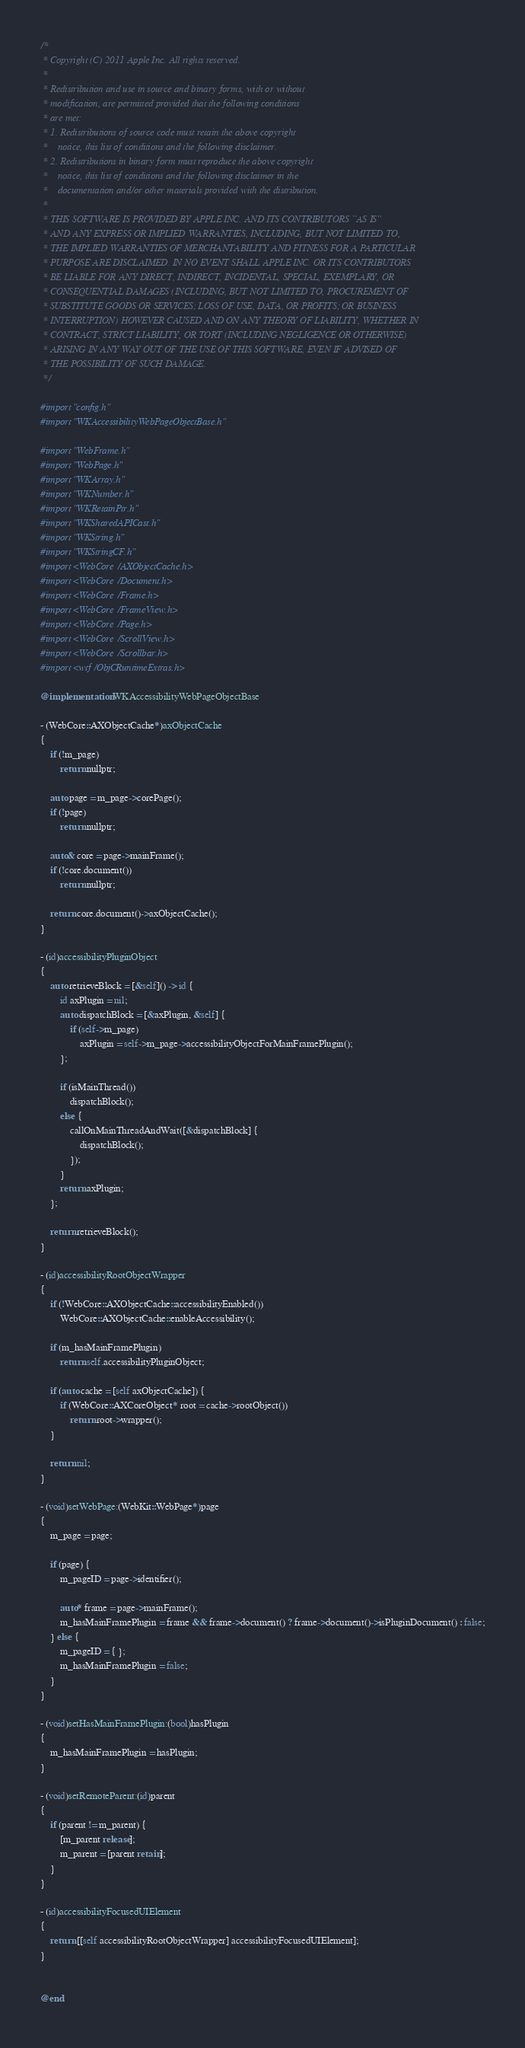Convert code to text. <code><loc_0><loc_0><loc_500><loc_500><_ObjectiveC_>/*
 * Copyright (C) 2011 Apple Inc. All rights reserved.
 *
 * Redistribution and use in source and binary forms, with or without
 * modification, are permitted provided that the following conditions
 * are met:
 * 1. Redistributions of source code must retain the above copyright
 *    notice, this list of conditions and the following disclaimer.
 * 2. Redistributions in binary form must reproduce the above copyright
 *    notice, this list of conditions and the following disclaimer in the
 *    documentation and/or other materials provided with the distribution.
 *
 * THIS SOFTWARE IS PROVIDED BY APPLE INC. AND ITS CONTRIBUTORS ``AS IS''
 * AND ANY EXPRESS OR IMPLIED WARRANTIES, INCLUDING, BUT NOT LIMITED TO,
 * THE IMPLIED WARRANTIES OF MERCHANTABILITY AND FITNESS FOR A PARTICULAR
 * PURPOSE ARE DISCLAIMED. IN NO EVENT SHALL APPLE INC. OR ITS CONTRIBUTORS
 * BE LIABLE FOR ANY DIRECT, INDIRECT, INCIDENTAL, SPECIAL, EXEMPLARY, OR
 * CONSEQUENTIAL DAMAGES (INCLUDING, BUT NOT LIMITED TO, PROCUREMENT OF
 * SUBSTITUTE GOODS OR SERVICES; LOSS OF USE, DATA, OR PROFITS; OR BUSINESS
 * INTERRUPTION) HOWEVER CAUSED AND ON ANY THEORY OF LIABILITY, WHETHER IN
 * CONTRACT, STRICT LIABILITY, OR TORT (INCLUDING NEGLIGENCE OR OTHERWISE)
 * ARISING IN ANY WAY OUT OF THE USE OF THIS SOFTWARE, EVEN IF ADVISED OF
 * THE POSSIBILITY OF SUCH DAMAGE.
 */

#import "config.h"
#import "WKAccessibilityWebPageObjectBase.h"

#import "WebFrame.h"
#import "WebPage.h"
#import "WKArray.h"
#import "WKNumber.h"
#import "WKRetainPtr.h"
#import "WKSharedAPICast.h"
#import "WKString.h"
#import "WKStringCF.h"
#import <WebCore/AXObjectCache.h>
#import <WebCore/Document.h>
#import <WebCore/Frame.h>
#import <WebCore/FrameView.h>
#import <WebCore/Page.h>
#import <WebCore/ScrollView.h>
#import <WebCore/Scrollbar.h>
#import <wtf/ObjCRuntimeExtras.h>

@implementation WKAccessibilityWebPageObjectBase

- (WebCore::AXObjectCache*)axObjectCache
{
    if (!m_page)
        return nullptr;

    auto page = m_page->corePage();
    if (!page)
        return nullptr;

    auto& core = page->mainFrame();
    if (!core.document())
        return nullptr;

    return core.document()->axObjectCache();
}

- (id)accessibilityPluginObject
{
    auto retrieveBlock = [&self]() -> id {
        id axPlugin = nil;
        auto dispatchBlock = [&axPlugin, &self] {
            if (self->m_page)
                axPlugin = self->m_page->accessibilityObjectForMainFramePlugin();
        };

        if (isMainThread())
            dispatchBlock();
        else {
            callOnMainThreadAndWait([&dispatchBlock] {
                dispatchBlock();
            });
        }
        return axPlugin;
    };
    
    return retrieveBlock();
}

- (id)accessibilityRootObjectWrapper
{
    if (!WebCore::AXObjectCache::accessibilityEnabled())
        WebCore::AXObjectCache::enableAccessibility();

    if (m_hasMainFramePlugin)
        return self.accessibilityPluginObject;

    if (auto cache = [self axObjectCache]) {
        if (WebCore::AXCoreObject* root = cache->rootObject())
            return root->wrapper();
    }

    return nil;
}

- (void)setWebPage:(WebKit::WebPage*)page
{
    m_page = page;

    if (page) {
        m_pageID = page->identifier();

        auto* frame = page->mainFrame();
        m_hasMainFramePlugin = frame && frame->document() ? frame->document()->isPluginDocument() : false;
    } else {
        m_pageID = { };
        m_hasMainFramePlugin = false;
    }
}

- (void)setHasMainFramePlugin:(bool)hasPlugin
{
    m_hasMainFramePlugin = hasPlugin;
}

- (void)setRemoteParent:(id)parent
{
    if (parent != m_parent) {
        [m_parent release];
        m_parent = [parent retain];
    }
}

- (id)accessibilityFocusedUIElement
{
    return [[self accessibilityRootObjectWrapper] accessibilityFocusedUIElement];
}


@end
</code> 